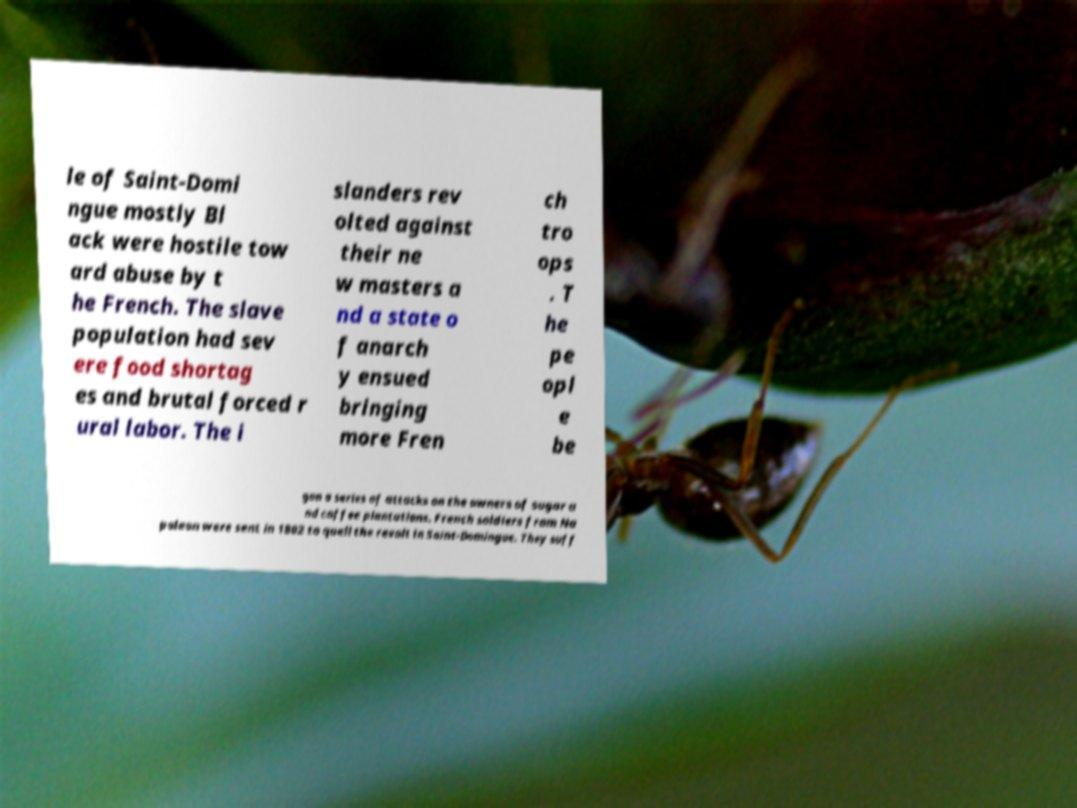For documentation purposes, I need the text within this image transcribed. Could you provide that? le of Saint-Domi ngue mostly Bl ack were hostile tow ard abuse by t he French. The slave population had sev ere food shortag es and brutal forced r ural labor. The i slanders rev olted against their ne w masters a nd a state o f anarch y ensued bringing more Fren ch tro ops . T he pe opl e be gan a series of attacks on the owners of sugar a nd coffee plantations. French soldiers from Na poleon were sent in 1802 to quell the revolt in Saint-Domingue. They suff 